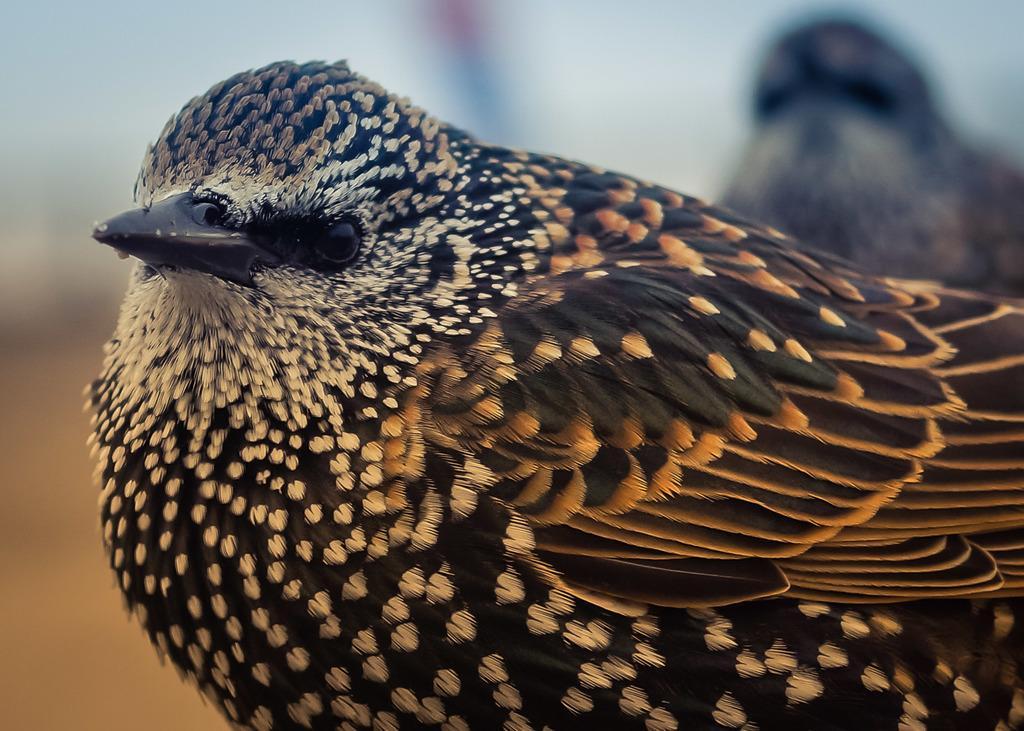In one or two sentences, can you explain what this image depicts? It is a bird in black and white color. 